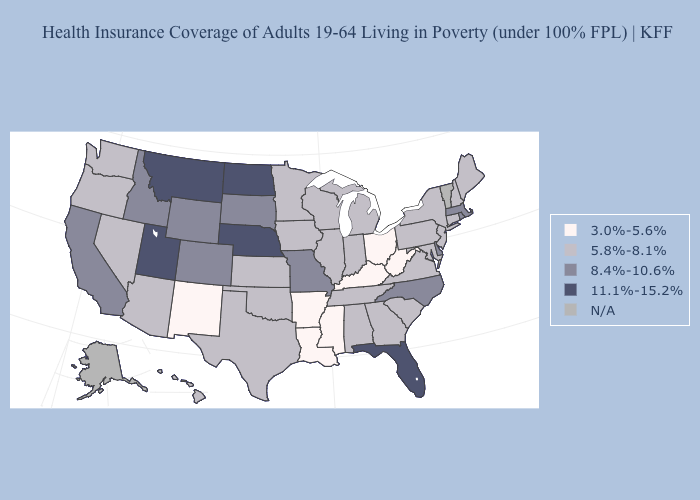What is the lowest value in states that border Montana?
Write a very short answer. 8.4%-10.6%. Among the states that border Oregon , does California have the highest value?
Be succinct. Yes. Name the states that have a value in the range 11.1%-15.2%?
Short answer required. Florida, Montana, Nebraska, North Dakota, Utah. Does Mississippi have the lowest value in the USA?
Keep it brief. Yes. Name the states that have a value in the range N/A?
Answer briefly. Alaska, Vermont. Name the states that have a value in the range 8.4%-10.6%?
Write a very short answer. California, Colorado, Delaware, Idaho, Massachusetts, Missouri, North Carolina, Rhode Island, South Dakota, Wyoming. Name the states that have a value in the range N/A?
Be succinct. Alaska, Vermont. Which states have the lowest value in the USA?
Quick response, please. Arkansas, Kentucky, Louisiana, Mississippi, New Mexico, Ohio, West Virginia. Among the states that border Georgia , which have the highest value?
Answer briefly. Florida. What is the value of Maine?
Write a very short answer. 5.8%-8.1%. Which states have the lowest value in the Northeast?
Quick response, please. Connecticut, Maine, New Hampshire, New Jersey, New York, Pennsylvania. Does Idaho have the highest value in the West?
Keep it brief. No. Which states have the lowest value in the Northeast?
Write a very short answer. Connecticut, Maine, New Hampshire, New Jersey, New York, Pennsylvania. What is the highest value in states that border New York?
Keep it brief. 8.4%-10.6%. What is the highest value in the MidWest ?
Quick response, please. 11.1%-15.2%. 